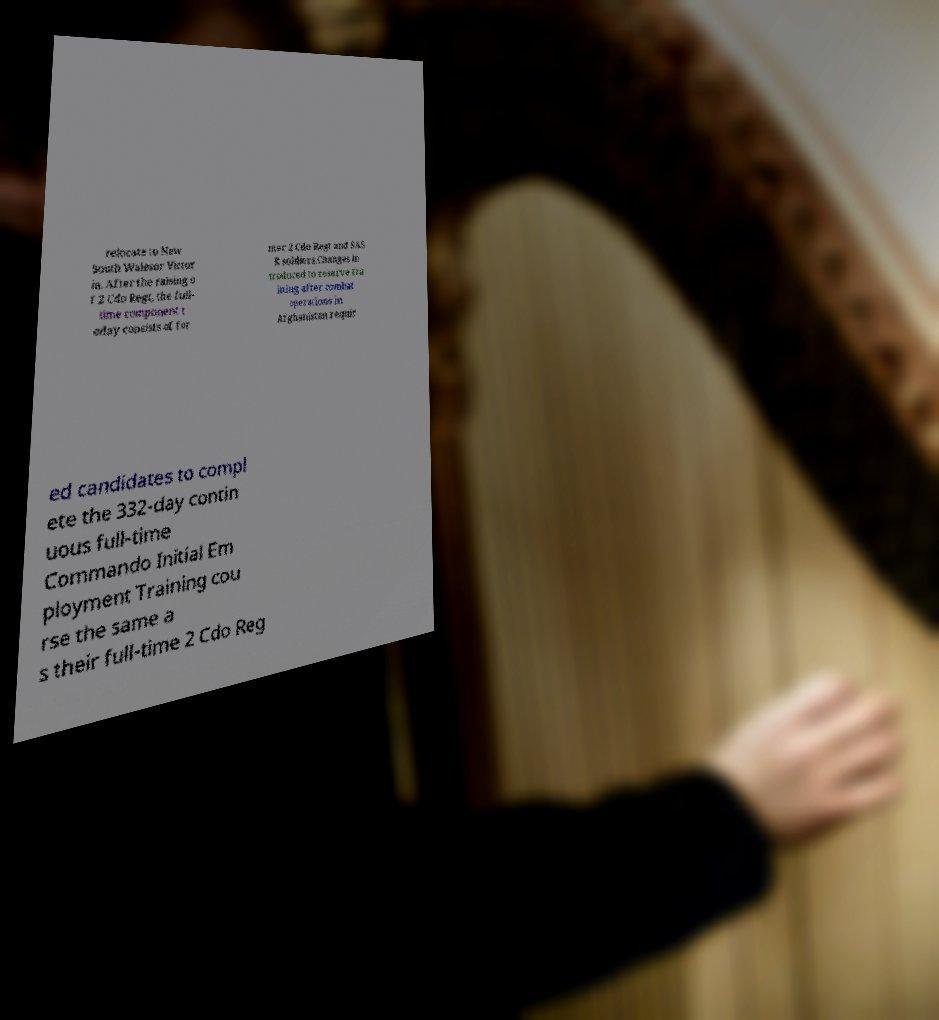I need the written content from this picture converted into text. Can you do that? relocate to New South Walesor Victor ia. After the raising o f 2 Cdo Regt, the full- time component t oday consists of for mer 2 Cdo Regt and SAS R soldiers.Changes in troduced to reserve tra ining after combat operations in Afghanistan requir ed candidates to compl ete the 332-day contin uous full-time Commando Initial Em ployment Training cou rse the same a s their full-time 2 Cdo Reg 